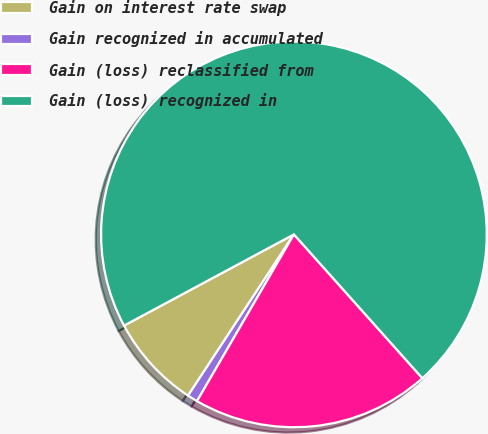Convert chart. <chart><loc_0><loc_0><loc_500><loc_500><pie_chart><fcel>Gain on interest rate swap<fcel>Gain recognized in accumulated<fcel>Gain (loss) reclassified from<fcel>Gain (loss) recognized in<nl><fcel>7.91%<fcel>0.87%<fcel>19.98%<fcel>71.24%<nl></chart> 